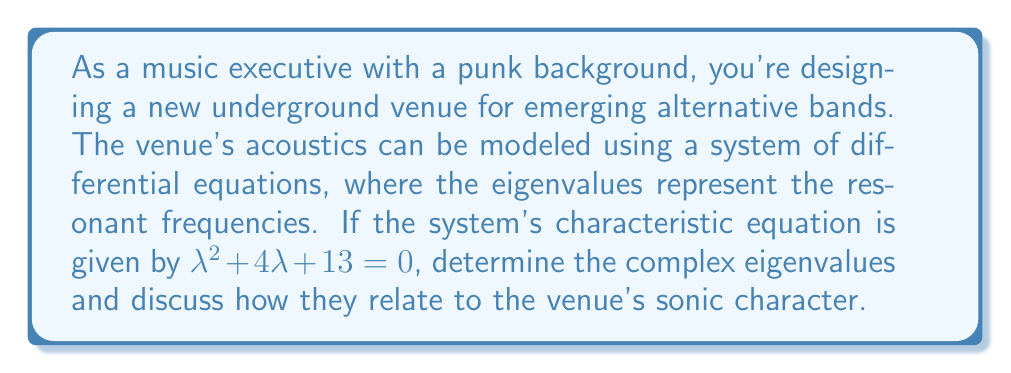Show me your answer to this math problem. To solve this problem, we'll follow these steps:

1) The characteristic equation is in the form $\lambda^2 + 4\lambda + 13 = 0$. This is a quadratic equation.

2) We can solve this using the quadratic formula: $\lambda = \frac{-b \pm \sqrt{b^2 - 4ac}}{2a}$

   Where $a = 1$, $b = 4$, and $c = 13$

3) Substituting these values:

   $\lambda = \frac{-4 \pm \sqrt{4^2 - 4(1)(13)}}{2(1)}$

4) Simplify under the square root:

   $\lambda = \frac{-4 \pm \sqrt{16 - 52}}{2} = \frac{-4 \pm \sqrt{-36}}{2}$

5) Simplify further:

   $\lambda = \frac{-4 \pm 6i}{2}$

6) This gives us two complex eigenvalues:

   $\lambda_1 = -2 + 3i$ and $\lambda_2 = -2 - 3i$

7) In terms of acoustics:
   - The real part (-2) represents the decay rate of the sound in the venue.
   - The imaginary part (±3) represents the oscillation frequency.

8) For a punk venue, this suggests:
   - A moderate decay rate, allowing for some reverberation but not too much.
   - A distinct resonant frequency, which could add character to the sound.

This combination would create a raw, energetic sound typical of punk venues, while still maintaining clarity - perfect for showcasing emerging alternative bands.
Answer: $\lambda_1 = -2 + 3i$, $\lambda_2 = -2 - 3i$ 